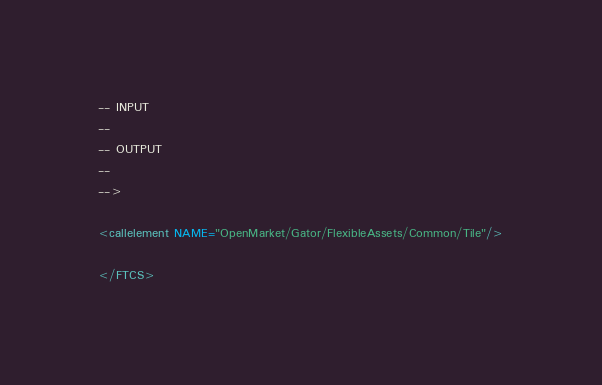<code> <loc_0><loc_0><loc_500><loc_500><_XML_>-- INPUT
--
-- OUTPUT
--
-->

<callelement NAME="OpenMarket/Gator/FlexibleAssets/Common/Tile"/>

</FTCS>
</code> 